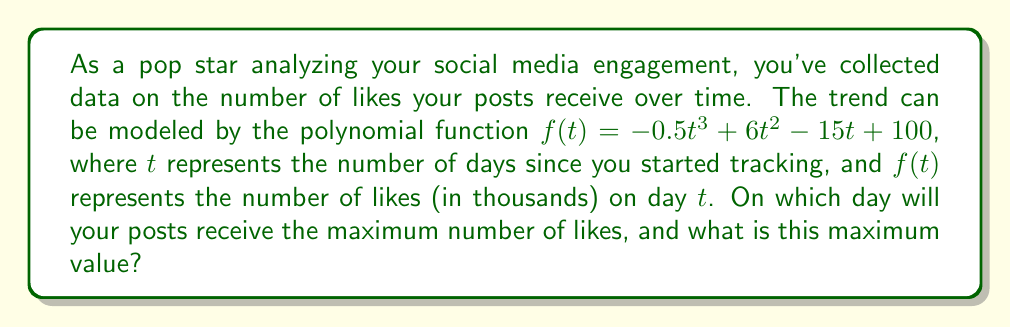What is the answer to this math problem? To find the day with maximum likes and the maximum value, we need to follow these steps:

1) First, we need to find the derivative of $f(t)$ to determine where the function reaches its maximum:

   $f'(t) = -1.5t^2 + 12t - 15$

2) Set $f'(t) = 0$ to find the critical points:

   $-1.5t^2 + 12t - 15 = 0$

3) This is a quadratic equation. We can solve it using the quadratic formula:

   $t = \frac{-b \pm \sqrt{b^2 - 4ac}}{2a}$

   Where $a = -1.5$, $b = 12$, and $c = -15$

4) Plugging in these values:

   $t = \frac{-12 \pm \sqrt{12^2 - 4(-1.5)(-15)}}{2(-1.5)}$
   
   $= \frac{-12 \pm \sqrt{144 - 90}}{-3}$
   
   $= \frac{-12 \pm \sqrt{54}}{-3}$
   
   $= \frac{-12 \pm 3\sqrt{6}}{-3}$

5) This gives us two solutions:

   $t_1 = \frac{-12 + 3\sqrt{6}}{-3} = 4 - \sqrt{6}$
   
   $t_2 = \frac{-12 - 3\sqrt{6}}{-3} = 4 + \sqrt{6}$

6) Since we're looking for the maximum, and the coefficient of $t^3$ in the original function is negative, the maximum occurs at the larger value of $t$, which is $4 + \sqrt{6}$.

7) To find the exact day, we round this to the nearest whole number:
   
   $4 + \sqrt{6} \approx 6.45$, which rounds to 6.

8) To find the maximum number of likes, we plug $t = 4 + \sqrt{6}$ back into the original function:

   $f(4 + \sqrt{6}) = -0.5(4 + \sqrt{6})^3 + 6(4 + \sqrt{6})^2 - 15(4 + \sqrt{6}) + 100$

9) Simplifying this (which involves some complex algebra) gives us approximately 114.5 thousand likes.
Answer: The posts will receive the maximum number of likes on day 6, with approximately 114,500 likes. 